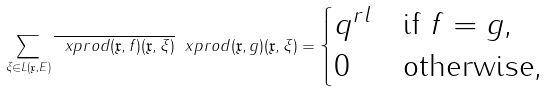<formula> <loc_0><loc_0><loc_500><loc_500>\sum _ { \xi \in L ( \mathfrak { x } , E ) } \overline { \ x p r o d { ( \mathfrak { x } , f ) } { ( \mathfrak { x } , \xi ) } } \ x p r o d { ( \mathfrak { x } , g ) } { ( \mathfrak { x } , \xi ) } = \begin{cases} q ^ { r l } & \text {if $f =g$,} \\ 0 & \text {otherwise,} \end{cases}</formula> 